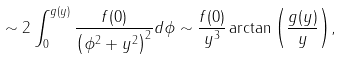Convert formula to latex. <formula><loc_0><loc_0><loc_500><loc_500>\sim 2 \int _ { 0 } ^ { g ( y ) } \frac { f ( 0 ) } { \left ( \phi ^ { 2 } + y ^ { 2 } \right ) ^ { 2 } } d \phi \sim \frac { f ( 0 ) } { y ^ { 3 } } \arctan { \left ( \frac { g ( y ) } { y } \right ) } , \\</formula> 